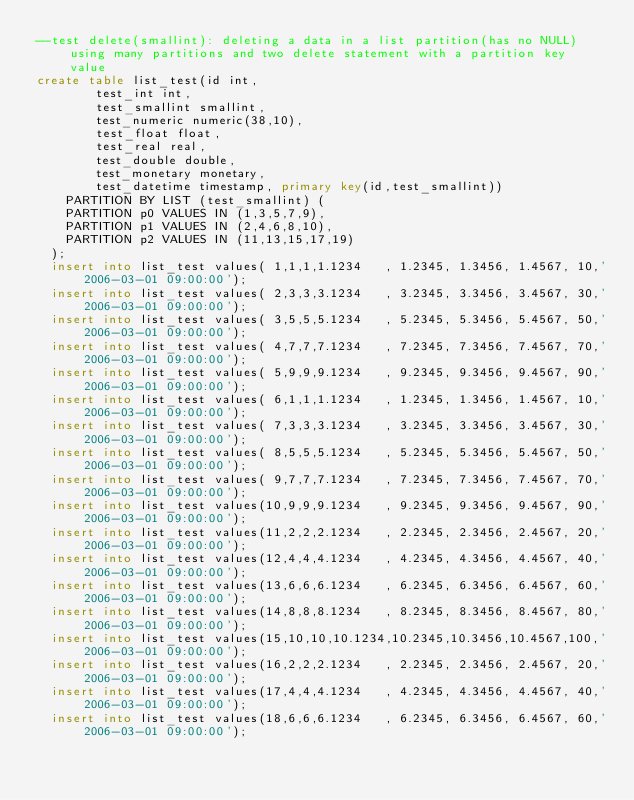Convert code to text. <code><loc_0><loc_0><loc_500><loc_500><_SQL_>--test delete(smallint): deleting a data in a list partition(has no NULL) using many partitions and two delete statement with a partition key value
create table list_test(id int,
				test_int int,
				test_smallint smallint,
				test_numeric numeric(38,10),
				test_float float,
				test_real real,
				test_double double,
				test_monetary monetary,
				test_datetime timestamp, primary key(id,test_smallint))
		PARTITION BY LIST (test_smallint) (
		PARTITION p0 VALUES IN (1,3,5,7,9),
		PARTITION p1 VALUES IN (2,4,6,8,10),
		PARTITION p2 VALUES IN (11,13,15,17,19)
	);
	insert into list_test values( 1,1,1,1.1234   , 1.2345, 1.3456, 1.4567, 10,'2006-03-01 09:00:00');
	insert into list_test values( 2,3,3,3.1234   , 3.2345, 3.3456, 3.4567, 30,'2006-03-01 09:00:00');
	insert into list_test values( 3,5,5,5.1234   , 5.2345, 5.3456, 5.4567, 50,'2006-03-01 09:00:00');
	insert into list_test values( 4,7,7,7.1234   , 7.2345, 7.3456, 7.4567, 70,'2006-03-01 09:00:00');
	insert into list_test values( 5,9,9,9.1234   , 9.2345, 9.3456, 9.4567, 90,'2006-03-01 09:00:00');
	insert into list_test values( 6,1,1,1.1234   , 1.2345, 1.3456, 1.4567, 10,'2006-03-01 09:00:00');
	insert into list_test values( 7,3,3,3.1234   , 3.2345, 3.3456, 3.4567, 30,'2006-03-01 09:00:00');
	insert into list_test values( 8,5,5,5.1234   , 5.2345, 5.3456, 5.4567, 50,'2006-03-01 09:00:00');
	insert into list_test values( 9,7,7,7.1234   , 7.2345, 7.3456, 7.4567, 70,'2006-03-01 09:00:00');
	insert into list_test values(10,9,9,9.1234   , 9.2345, 9.3456, 9.4567, 90,'2006-03-01 09:00:00');
	insert into list_test values(11,2,2,2.1234   , 2.2345, 2.3456, 2.4567, 20,'2006-03-01 09:00:00');
	insert into list_test values(12,4,4,4.1234   , 4.2345, 4.3456, 4.4567, 40,'2006-03-01 09:00:00');
	insert into list_test values(13,6,6,6.1234   , 6.2345, 6.3456, 6.4567, 60,'2006-03-01 09:00:00');
	insert into list_test values(14,8,8,8.1234   , 8.2345, 8.3456, 8.4567, 80,'2006-03-01 09:00:00');
	insert into list_test values(15,10,10,10.1234,10.2345,10.3456,10.4567,100,'2006-03-01 09:00:00');
	insert into list_test values(16,2,2,2.1234   , 2.2345, 2.3456, 2.4567, 20,'2006-03-01 09:00:00');
	insert into list_test values(17,4,4,4.1234   , 4.2345, 4.3456, 4.4567, 40,'2006-03-01 09:00:00');
	insert into list_test values(18,6,6,6.1234   , 6.2345, 6.3456, 6.4567, 60,'2006-03-01 09:00:00');</code> 